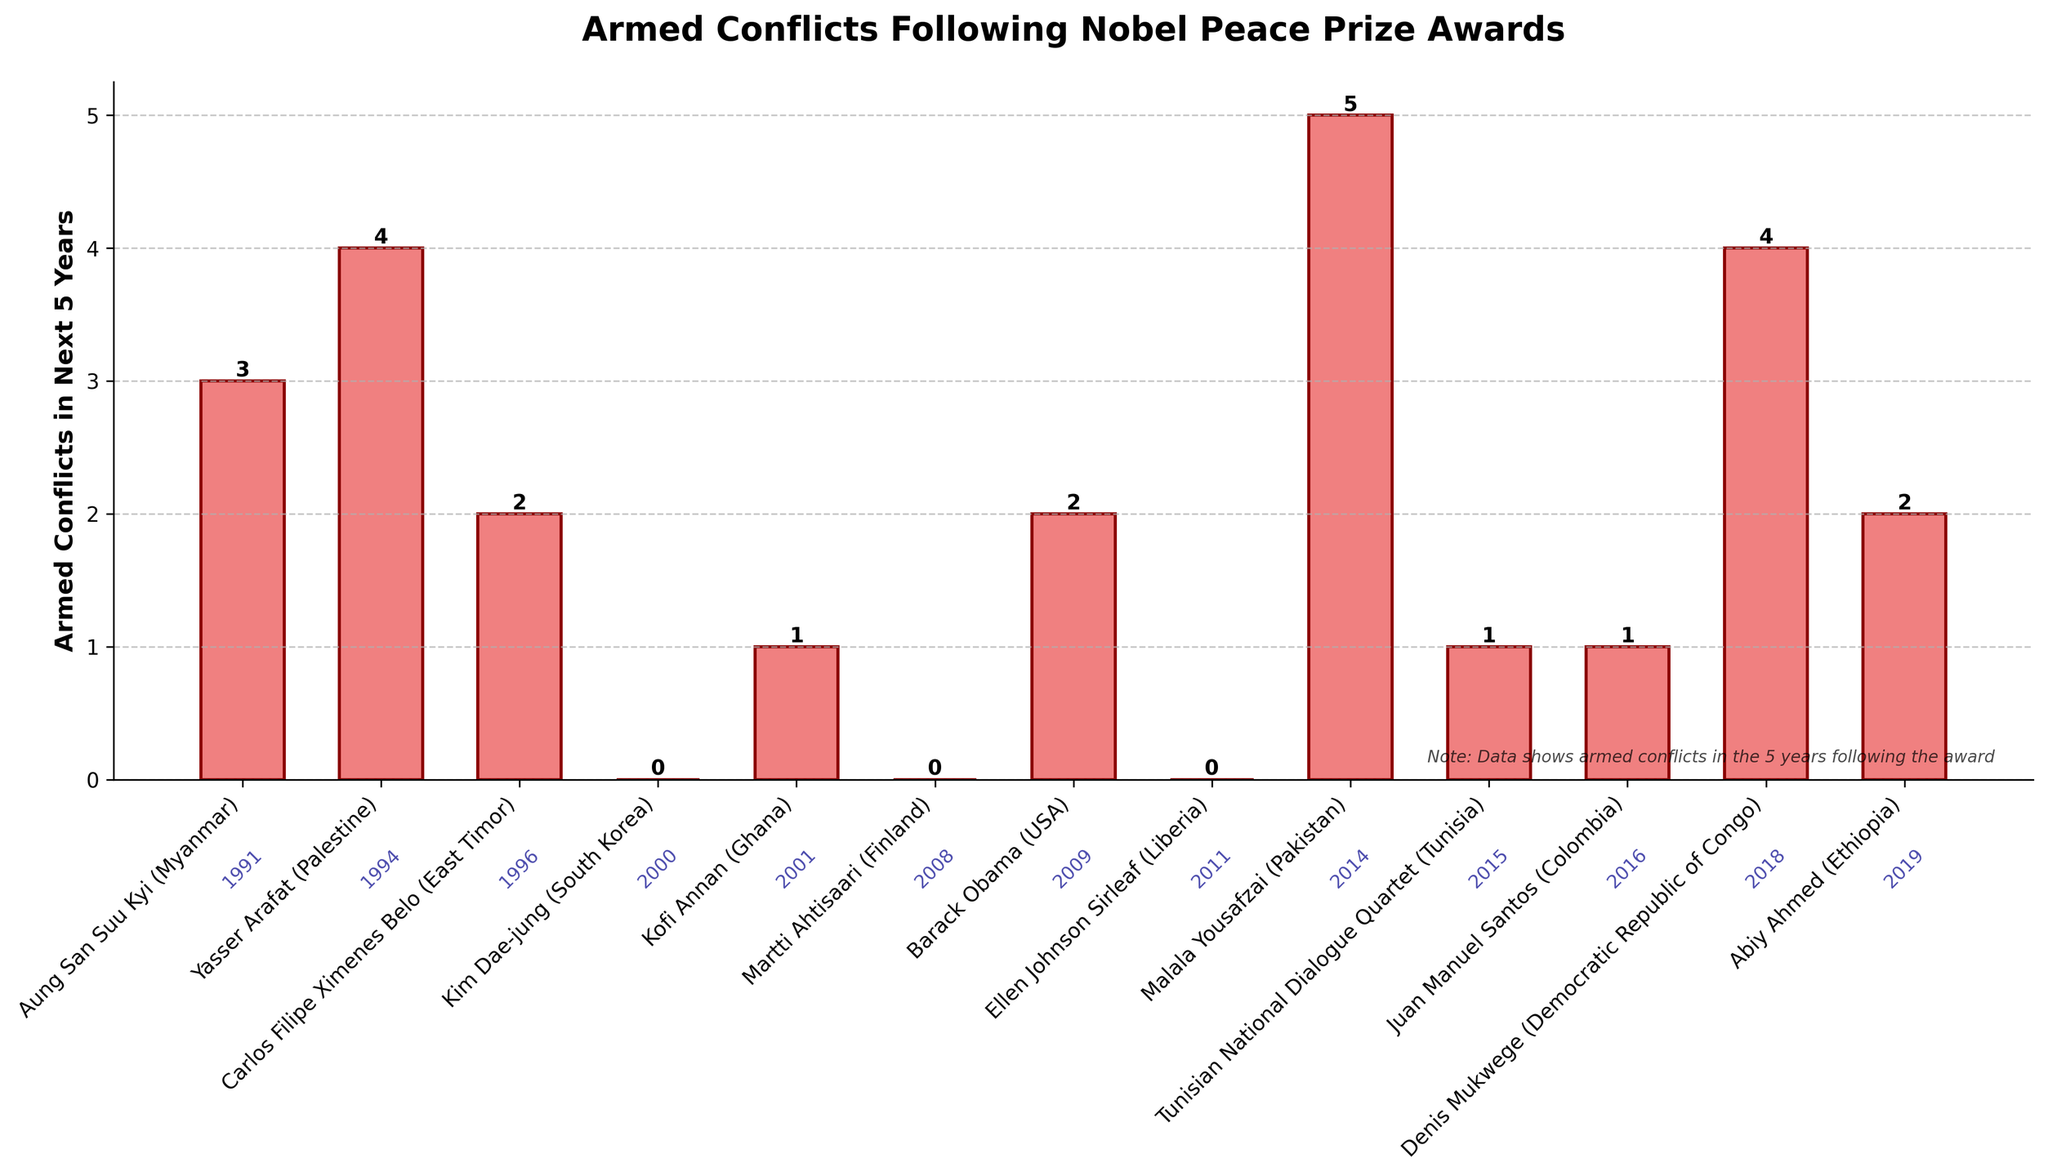What is the total number of armed conflicts in the next 5 years across all countries listed? Add the number of armed conflicts for each country. The total is 3 + 4 + 2 + 0 + 1 + 0 + 2 + 0 + 5 + 1 + 1 + 4 + 2 = 25
Answer: 25 Which Nobel Peace Prize winner's country experienced the highest number of armed conflicts in the next 5 years? Compare the height of all the bars. The highest bar represents Malala Yousafzai (Pakistan) with 5 armed conflicts.
Answer: Malala Yousafzai (Pakistan) How many Nobel Peace Prize winners' countries experienced no armed conflicts in the next 5 years? Count the bars with zero height (or no value above them). The countries are Kim Dae-jung (South Korea), Martti Ahtisaari (Finland), and Ellen Johnson Sirleaf (Liberia), which makes 3 in total.
Answer: 3 What's the average number of armed conflicts in the next 5 years for the given Nobel Peace Prize winners' countries? Sum the armed conflicts (25) and divide by the number of winners (13). The average is 25/13 ≈ 1.92
Answer: ≈ 1.92 Compare the number of armed conflicts in the next 5 years between Barack Obama (USA) and Abiy Ahmed (Ethiopia). Who had a higher number? Look for the heights of the bars representing Barack Obama (USA) and Abiy Ahmed (Ethiopia). Barack Obama (USA) has 2 conflicts and Abiy Ahmed (Ethiopia) also has 2 conflicts. Therefore, they are equal.
Answer: Equal Which year had the highest number of armed conflicts in the next 5 years following the Nobel Peace Prize award? Identify the bar with the highest value and its corresponding year. Malala Yousafzai (Pakistan) won in 2014, and her country experienced the highest number of conflicts (5).
Answer: 2014 How many countries experienced more than 3 armed conflicts in the next 5 years following the Nobel Peace Prize award? Count the bars with values greater than 3. The countries are Aung San Suu Kyi (Myanmar) with 3, Yasser Arafat (Palestine) with 4, Denis Mukwege (Democratic Republic of Congo) with 4, and Malala Yousafzai (Pakistan) with 5. Therefore, 3 countries have values greater than 3.
Answer: 3 Comparing the years 2014 and 2016, what is the difference in the number of armed conflicts in the next 5 years following the Nobel Peace Prize award? Identify the number of conflicts for 2014 (Malala Yousafzai, 5 conflicts) and 2016 (Juan Manuel Santos, 1 conflict). The difference is 5 - 1 = 4.
Answer: 4 What's the median number of armed conflicts in the next 5 years after the Nobel Peace Prize award? Arrange the number of conflicts in ascending order: 0, 0, 0, 1, 1, 1, 2, 2, 2, 3, 4, 4, 5. The middle value of 13 numbers is the 7th value, which is 2.
Answer: 2 